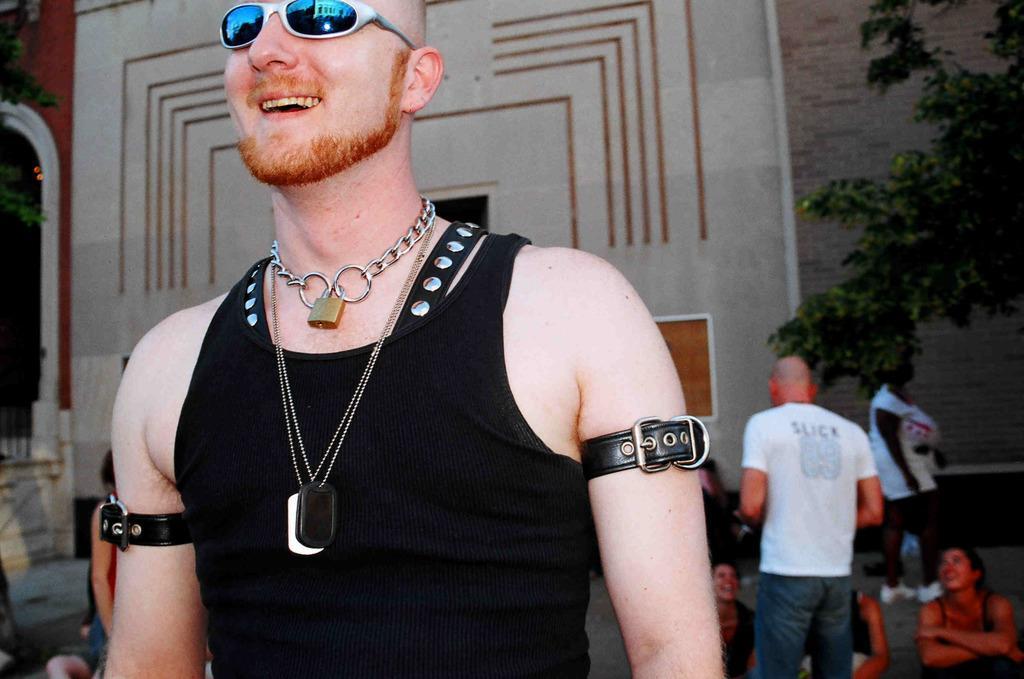Describe this image in one or two sentences. In the foreground of picture there is a man wearing spectacles and black dress. In the background there are people. On the right there is a tree. In the background it is well. On the left there is a tree and staircase. 